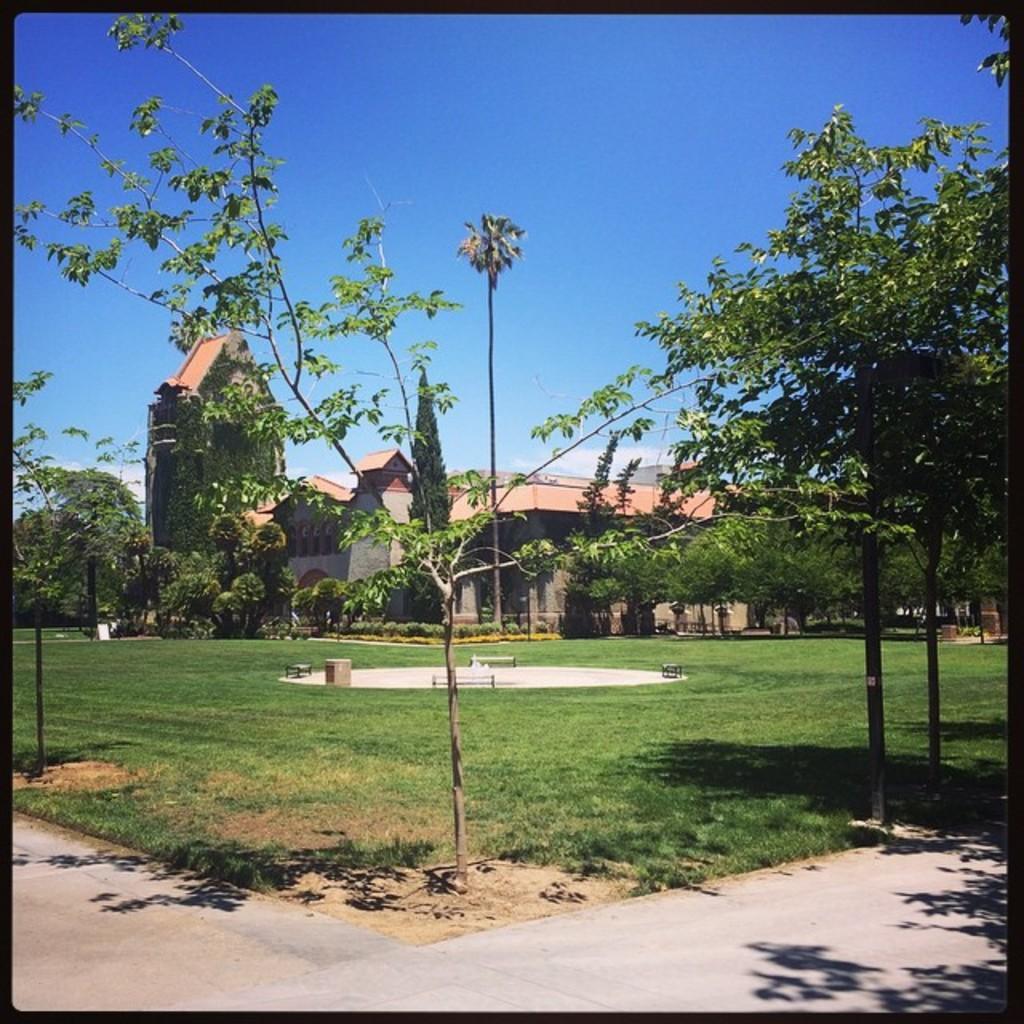How would you summarize this image in a sentence or two? In this picture we can see a fountain area covered with grass, trees & a walking path. In the background, we can see a house. The sky is blue. 